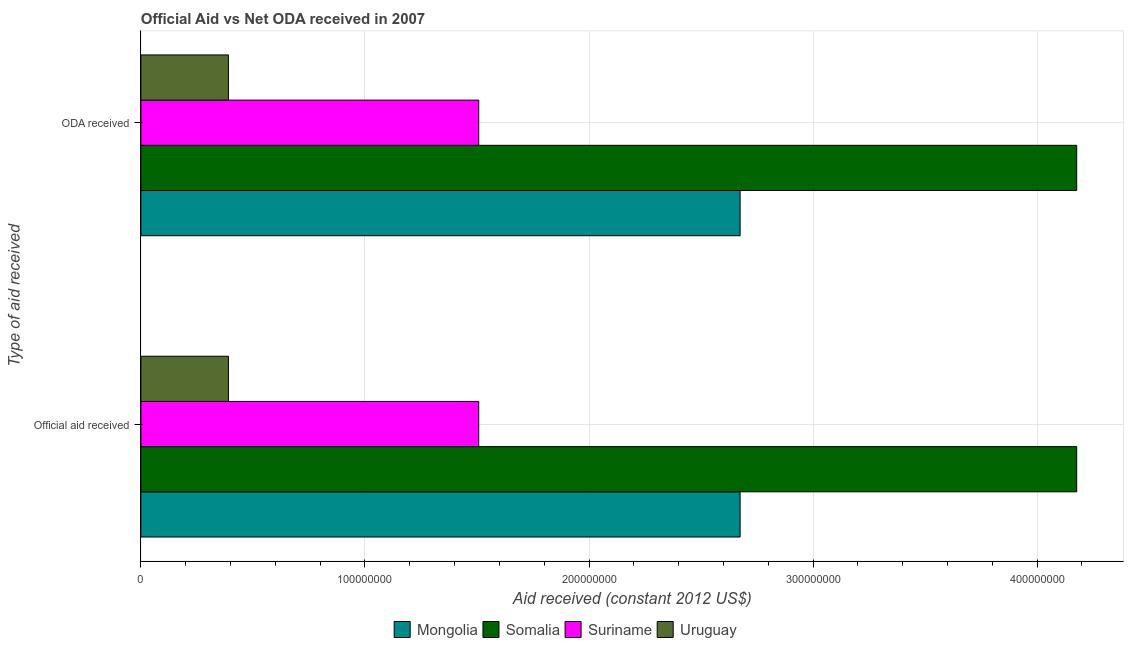How many groups of bars are there?
Your answer should be compact. 2. Are the number of bars per tick equal to the number of legend labels?
Your answer should be compact. Yes. Are the number of bars on each tick of the Y-axis equal?
Keep it short and to the point. Yes. How many bars are there on the 1st tick from the top?
Offer a terse response. 4. What is the label of the 1st group of bars from the top?
Ensure brevity in your answer.  ODA received. What is the official aid received in Mongolia?
Provide a short and direct response. 2.67e+08. Across all countries, what is the maximum oda received?
Keep it short and to the point. 4.18e+08. Across all countries, what is the minimum official aid received?
Keep it short and to the point. 3.91e+07. In which country was the oda received maximum?
Your answer should be compact. Somalia. In which country was the official aid received minimum?
Provide a succinct answer. Uruguay. What is the total official aid received in the graph?
Keep it short and to the point. 8.75e+08. What is the difference between the oda received in Uruguay and that in Mongolia?
Provide a succinct answer. -2.28e+08. What is the difference between the official aid received in Mongolia and the oda received in Somalia?
Your answer should be compact. -1.50e+08. What is the average official aid received per country?
Offer a very short reply. 2.19e+08. In how many countries, is the official aid received greater than 340000000 US$?
Your answer should be very brief. 1. What is the ratio of the official aid received in Somalia to that in Mongolia?
Your response must be concise. 1.56. Is the oda received in Uruguay less than that in Suriname?
Your answer should be very brief. Yes. In how many countries, is the oda received greater than the average oda received taken over all countries?
Give a very brief answer. 2. What does the 1st bar from the top in ODA received represents?
Your answer should be compact. Uruguay. What does the 1st bar from the bottom in Official aid received represents?
Provide a short and direct response. Mongolia. How many bars are there?
Make the answer very short. 8. Are all the bars in the graph horizontal?
Offer a terse response. Yes. How many countries are there in the graph?
Provide a short and direct response. 4. How many legend labels are there?
Ensure brevity in your answer.  4. What is the title of the graph?
Give a very brief answer. Official Aid vs Net ODA received in 2007 . What is the label or title of the X-axis?
Keep it short and to the point. Aid received (constant 2012 US$). What is the label or title of the Y-axis?
Make the answer very short. Type of aid received. What is the Aid received (constant 2012 US$) in Mongolia in Official aid received?
Make the answer very short. 2.67e+08. What is the Aid received (constant 2012 US$) in Somalia in Official aid received?
Offer a terse response. 4.18e+08. What is the Aid received (constant 2012 US$) in Suriname in Official aid received?
Provide a short and direct response. 1.51e+08. What is the Aid received (constant 2012 US$) in Uruguay in Official aid received?
Your response must be concise. 3.91e+07. What is the Aid received (constant 2012 US$) in Mongolia in ODA received?
Your answer should be compact. 2.67e+08. What is the Aid received (constant 2012 US$) of Somalia in ODA received?
Your answer should be compact. 4.18e+08. What is the Aid received (constant 2012 US$) of Suriname in ODA received?
Your answer should be very brief. 1.51e+08. What is the Aid received (constant 2012 US$) of Uruguay in ODA received?
Your response must be concise. 3.91e+07. Across all Type of aid received, what is the maximum Aid received (constant 2012 US$) of Mongolia?
Your response must be concise. 2.67e+08. Across all Type of aid received, what is the maximum Aid received (constant 2012 US$) in Somalia?
Your response must be concise. 4.18e+08. Across all Type of aid received, what is the maximum Aid received (constant 2012 US$) of Suriname?
Your answer should be compact. 1.51e+08. Across all Type of aid received, what is the maximum Aid received (constant 2012 US$) of Uruguay?
Keep it short and to the point. 3.91e+07. Across all Type of aid received, what is the minimum Aid received (constant 2012 US$) of Mongolia?
Make the answer very short. 2.67e+08. Across all Type of aid received, what is the minimum Aid received (constant 2012 US$) in Somalia?
Provide a succinct answer. 4.18e+08. Across all Type of aid received, what is the minimum Aid received (constant 2012 US$) of Suriname?
Give a very brief answer. 1.51e+08. Across all Type of aid received, what is the minimum Aid received (constant 2012 US$) of Uruguay?
Give a very brief answer. 3.91e+07. What is the total Aid received (constant 2012 US$) of Mongolia in the graph?
Offer a very short reply. 5.35e+08. What is the total Aid received (constant 2012 US$) in Somalia in the graph?
Your response must be concise. 8.35e+08. What is the total Aid received (constant 2012 US$) in Suriname in the graph?
Your answer should be compact. 3.02e+08. What is the total Aid received (constant 2012 US$) of Uruguay in the graph?
Ensure brevity in your answer.  7.81e+07. What is the difference between the Aid received (constant 2012 US$) of Mongolia in Official aid received and that in ODA received?
Make the answer very short. 0. What is the difference between the Aid received (constant 2012 US$) of Somalia in Official aid received and that in ODA received?
Make the answer very short. 0. What is the difference between the Aid received (constant 2012 US$) in Uruguay in Official aid received and that in ODA received?
Provide a succinct answer. 0. What is the difference between the Aid received (constant 2012 US$) of Mongolia in Official aid received and the Aid received (constant 2012 US$) of Somalia in ODA received?
Your response must be concise. -1.50e+08. What is the difference between the Aid received (constant 2012 US$) of Mongolia in Official aid received and the Aid received (constant 2012 US$) of Suriname in ODA received?
Provide a succinct answer. 1.17e+08. What is the difference between the Aid received (constant 2012 US$) of Mongolia in Official aid received and the Aid received (constant 2012 US$) of Uruguay in ODA received?
Keep it short and to the point. 2.28e+08. What is the difference between the Aid received (constant 2012 US$) in Somalia in Official aid received and the Aid received (constant 2012 US$) in Suriname in ODA received?
Ensure brevity in your answer.  2.67e+08. What is the difference between the Aid received (constant 2012 US$) in Somalia in Official aid received and the Aid received (constant 2012 US$) in Uruguay in ODA received?
Offer a terse response. 3.79e+08. What is the difference between the Aid received (constant 2012 US$) of Suriname in Official aid received and the Aid received (constant 2012 US$) of Uruguay in ODA received?
Your answer should be very brief. 1.12e+08. What is the average Aid received (constant 2012 US$) of Mongolia per Type of aid received?
Give a very brief answer. 2.67e+08. What is the average Aid received (constant 2012 US$) in Somalia per Type of aid received?
Make the answer very short. 4.18e+08. What is the average Aid received (constant 2012 US$) in Suriname per Type of aid received?
Make the answer very short. 1.51e+08. What is the average Aid received (constant 2012 US$) of Uruguay per Type of aid received?
Give a very brief answer. 3.91e+07. What is the difference between the Aid received (constant 2012 US$) in Mongolia and Aid received (constant 2012 US$) in Somalia in Official aid received?
Provide a short and direct response. -1.50e+08. What is the difference between the Aid received (constant 2012 US$) of Mongolia and Aid received (constant 2012 US$) of Suriname in Official aid received?
Your answer should be compact. 1.17e+08. What is the difference between the Aid received (constant 2012 US$) in Mongolia and Aid received (constant 2012 US$) in Uruguay in Official aid received?
Provide a short and direct response. 2.28e+08. What is the difference between the Aid received (constant 2012 US$) in Somalia and Aid received (constant 2012 US$) in Suriname in Official aid received?
Offer a terse response. 2.67e+08. What is the difference between the Aid received (constant 2012 US$) in Somalia and Aid received (constant 2012 US$) in Uruguay in Official aid received?
Ensure brevity in your answer.  3.79e+08. What is the difference between the Aid received (constant 2012 US$) of Suriname and Aid received (constant 2012 US$) of Uruguay in Official aid received?
Keep it short and to the point. 1.12e+08. What is the difference between the Aid received (constant 2012 US$) in Mongolia and Aid received (constant 2012 US$) in Somalia in ODA received?
Provide a short and direct response. -1.50e+08. What is the difference between the Aid received (constant 2012 US$) in Mongolia and Aid received (constant 2012 US$) in Suriname in ODA received?
Your answer should be compact. 1.17e+08. What is the difference between the Aid received (constant 2012 US$) in Mongolia and Aid received (constant 2012 US$) in Uruguay in ODA received?
Offer a very short reply. 2.28e+08. What is the difference between the Aid received (constant 2012 US$) in Somalia and Aid received (constant 2012 US$) in Suriname in ODA received?
Provide a succinct answer. 2.67e+08. What is the difference between the Aid received (constant 2012 US$) of Somalia and Aid received (constant 2012 US$) of Uruguay in ODA received?
Provide a short and direct response. 3.79e+08. What is the difference between the Aid received (constant 2012 US$) in Suriname and Aid received (constant 2012 US$) in Uruguay in ODA received?
Offer a terse response. 1.12e+08. What is the ratio of the Aid received (constant 2012 US$) in Mongolia in Official aid received to that in ODA received?
Offer a terse response. 1. What is the ratio of the Aid received (constant 2012 US$) of Somalia in Official aid received to that in ODA received?
Offer a very short reply. 1. What is the ratio of the Aid received (constant 2012 US$) of Suriname in Official aid received to that in ODA received?
Your answer should be compact. 1. What is the difference between the highest and the second highest Aid received (constant 2012 US$) in Uruguay?
Offer a very short reply. 0. What is the difference between the highest and the lowest Aid received (constant 2012 US$) in Somalia?
Your answer should be compact. 0. What is the difference between the highest and the lowest Aid received (constant 2012 US$) of Suriname?
Your response must be concise. 0. 